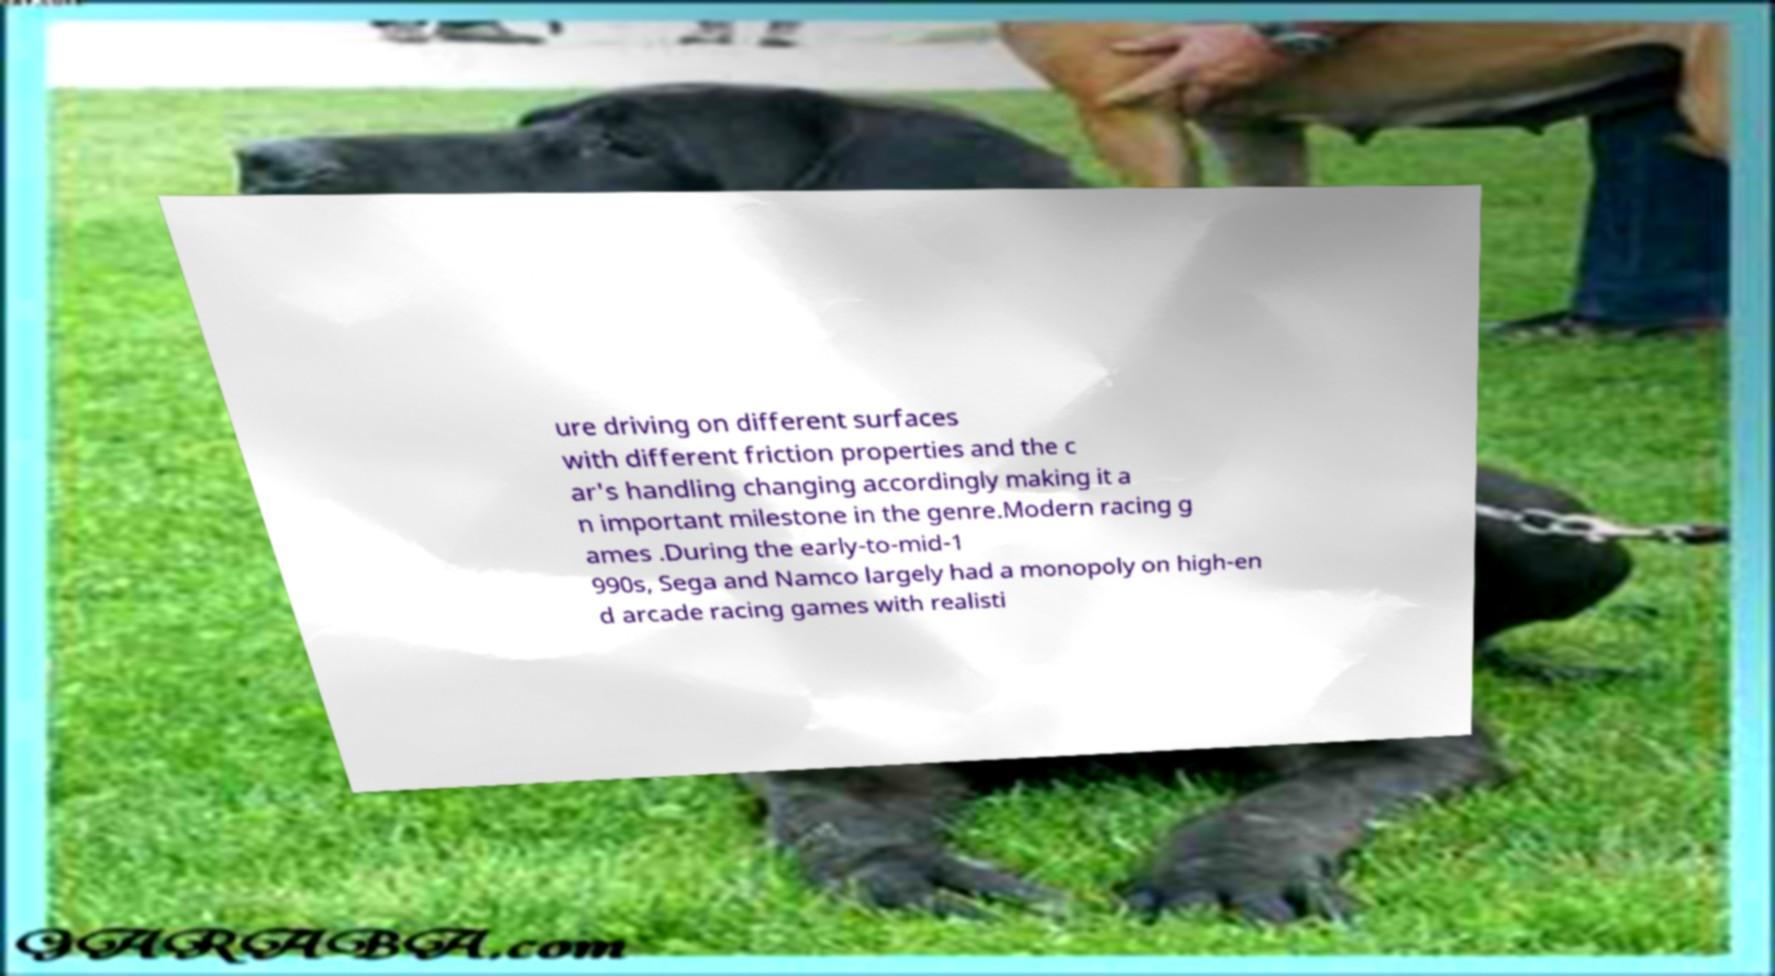Can you accurately transcribe the text from the provided image for me? ure driving on different surfaces with different friction properties and the c ar's handling changing accordingly making it a n important milestone in the genre.Modern racing g ames .During the early-to-mid-1 990s, Sega and Namco largely had a monopoly on high-en d arcade racing games with realisti 